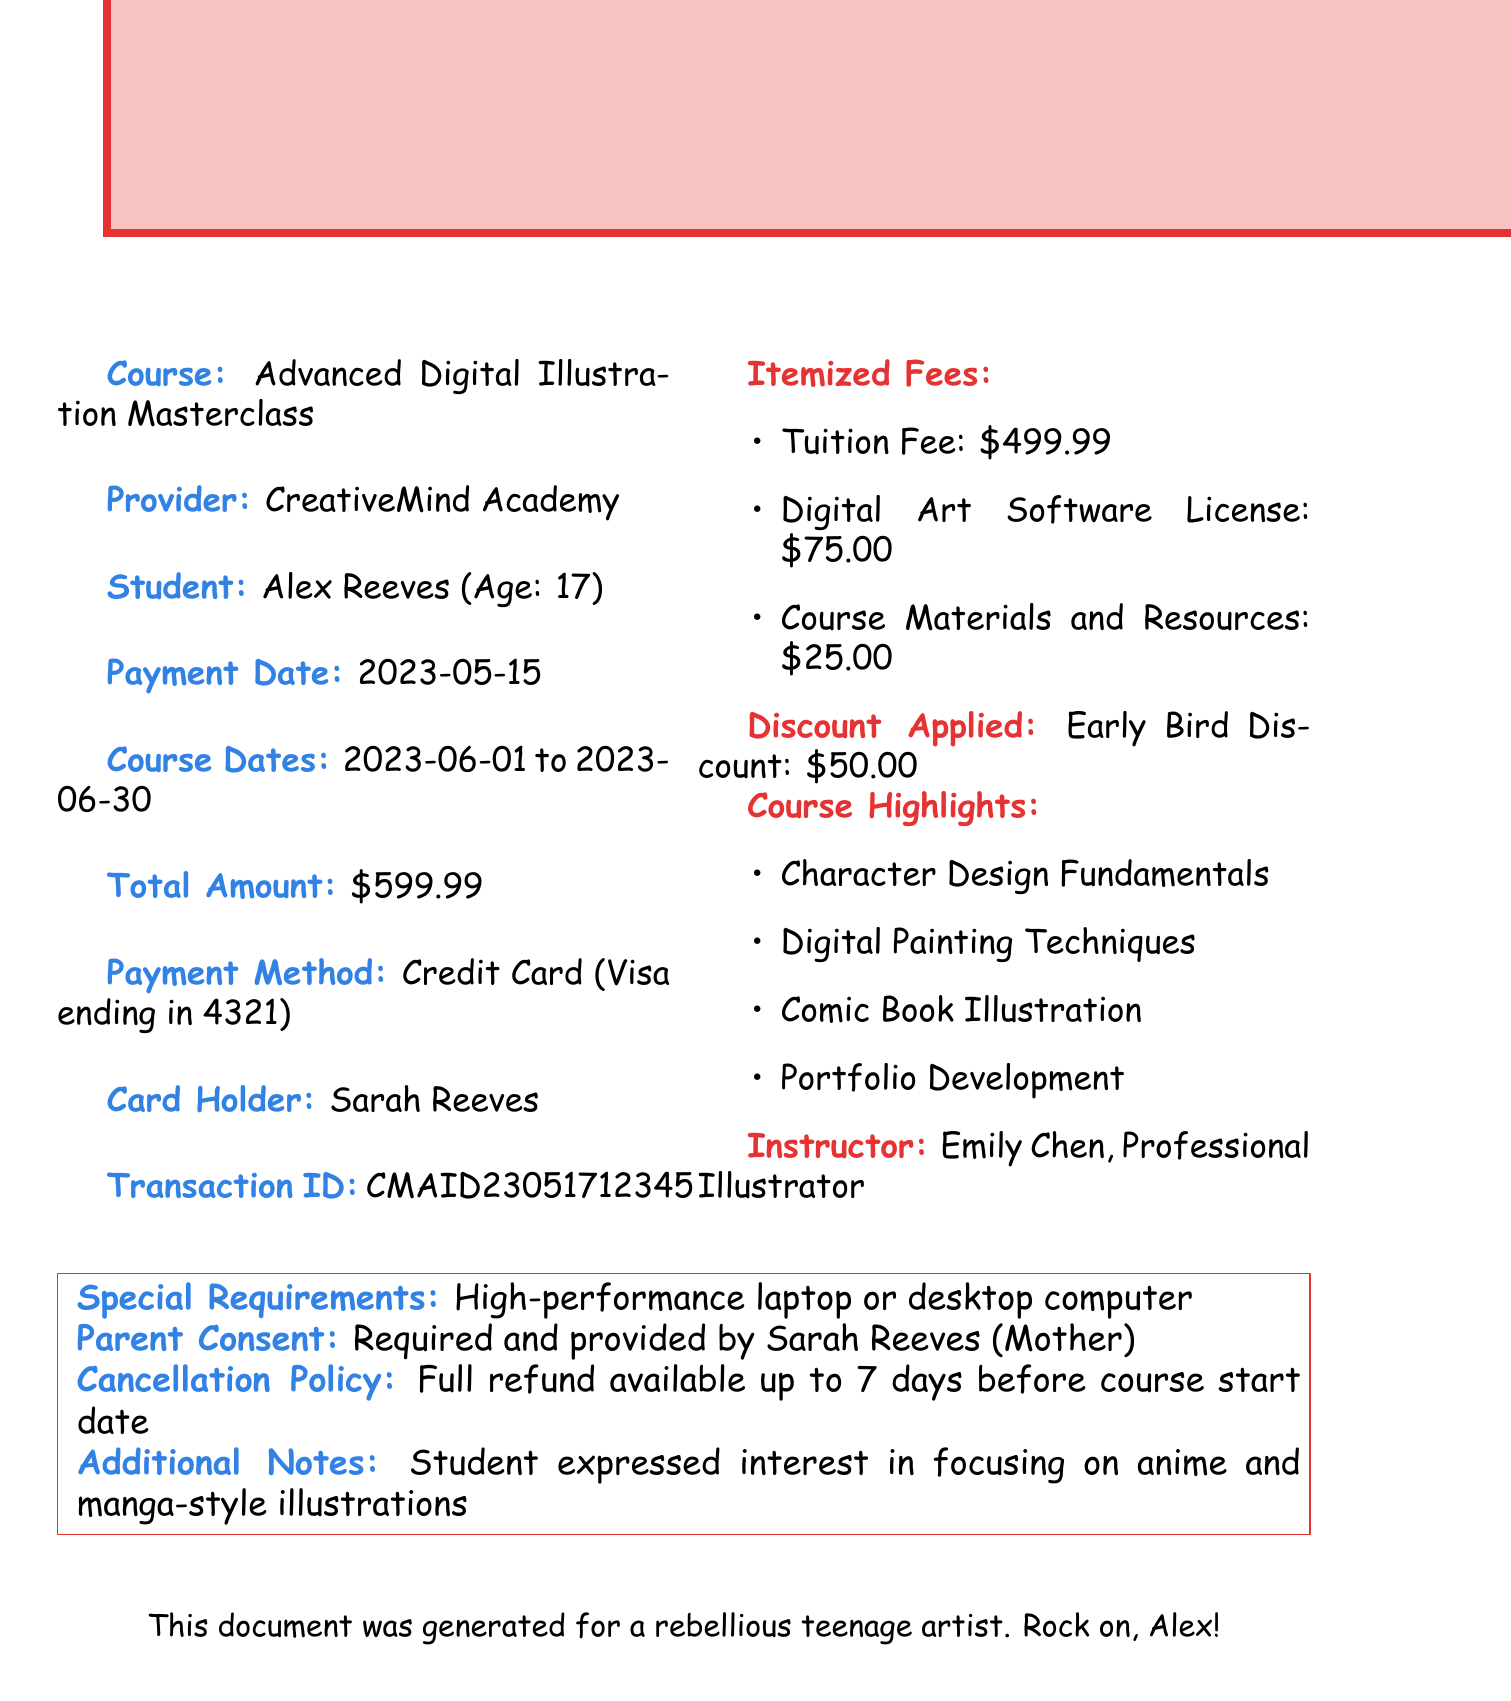what is the course name? The course name is listed under the main details, which is "Advanced Digital Illustration Masterclass".
Answer: Advanced Digital Illustration Masterclass who is the course provider? The provider of the course is mentioned right after the course name.
Answer: CreativeMind Academy what is the total amount paid? The total amount is stated at the bottom of the payment details section.
Answer: $599.99 what type of discount was applied? The discount type is included in the itemized details under "Discount Applied".
Answer: Early Bird Discount what is the transaction ID? The transaction ID can be found in the payment details section of the document.
Answer: CMAID23051712345 how many days before the course start date is a refund available? The cancellation policy specifies the timeframe for a full refund before the course starts.
Answer: 7 days what is the name of the instructor? The instructor's name is explicitly mentioned in the course highlights section.
Answer: Emily Chen what software license is included in the fees? The itemized fees list includes the specific software license that is part of the course cost.
Answer: Adobe Creative Suite what special requirement is specified for the course? The special requirement is detailed in the section about course necessities towards the end of the document.
Answer: High-performance laptop or desktop computer 